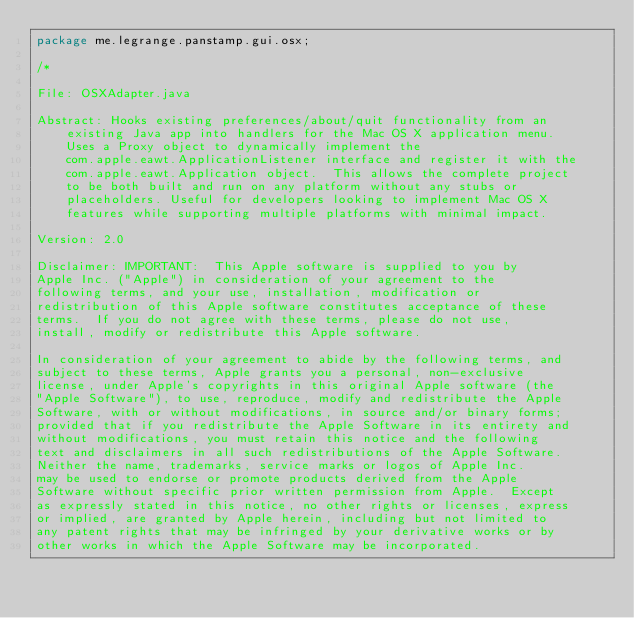Convert code to text. <code><loc_0><loc_0><loc_500><loc_500><_Java_>package me.legrange.panstamp.gui.osx;

/*
 
File: OSXAdapter.java
 
Abstract: Hooks existing preferences/about/quit functionality from an
    existing Java app into handlers for the Mac OS X application menu.
    Uses a Proxy object to dynamically implement the 
    com.apple.eawt.ApplicationListener interface and register it with the
    com.apple.eawt.Application object.  This allows the complete project
    to be both built and run on any platform without any stubs or 
    placeholders. Useful for developers looking to implement Mac OS X 
    features while supporting multiple platforms with minimal impact.
            
Version: 2.0
 
Disclaimer: IMPORTANT:  This Apple software is supplied to you by 
Apple Inc. ("Apple") in consideration of your agreement to the
following terms, and your use, installation, modification or
redistribution of this Apple software constitutes acceptance of these
terms.  If you do not agree with these terms, please do not use,
install, modify or redistribute this Apple software.
 
In consideration of your agreement to abide by the following terms, and
subject to these terms, Apple grants you a personal, non-exclusive
license, under Apple's copyrights in this original Apple software (the
"Apple Software"), to use, reproduce, modify and redistribute the Apple
Software, with or without modifications, in source and/or binary forms;
provided that if you redistribute the Apple Software in its entirety and
without modifications, you must retain this notice and the following
text and disclaimers in all such redistributions of the Apple Software. 
Neither the name, trademarks, service marks or logos of Apple Inc. 
may be used to endorse or promote products derived from the Apple
Software without specific prior written permission from Apple.  Except
as expressly stated in this notice, no other rights or licenses, express
or implied, are granted by Apple herein, including but not limited to
any patent rights that may be infringed by your derivative works or by
other works in which the Apple Software may be incorporated.
 </code> 